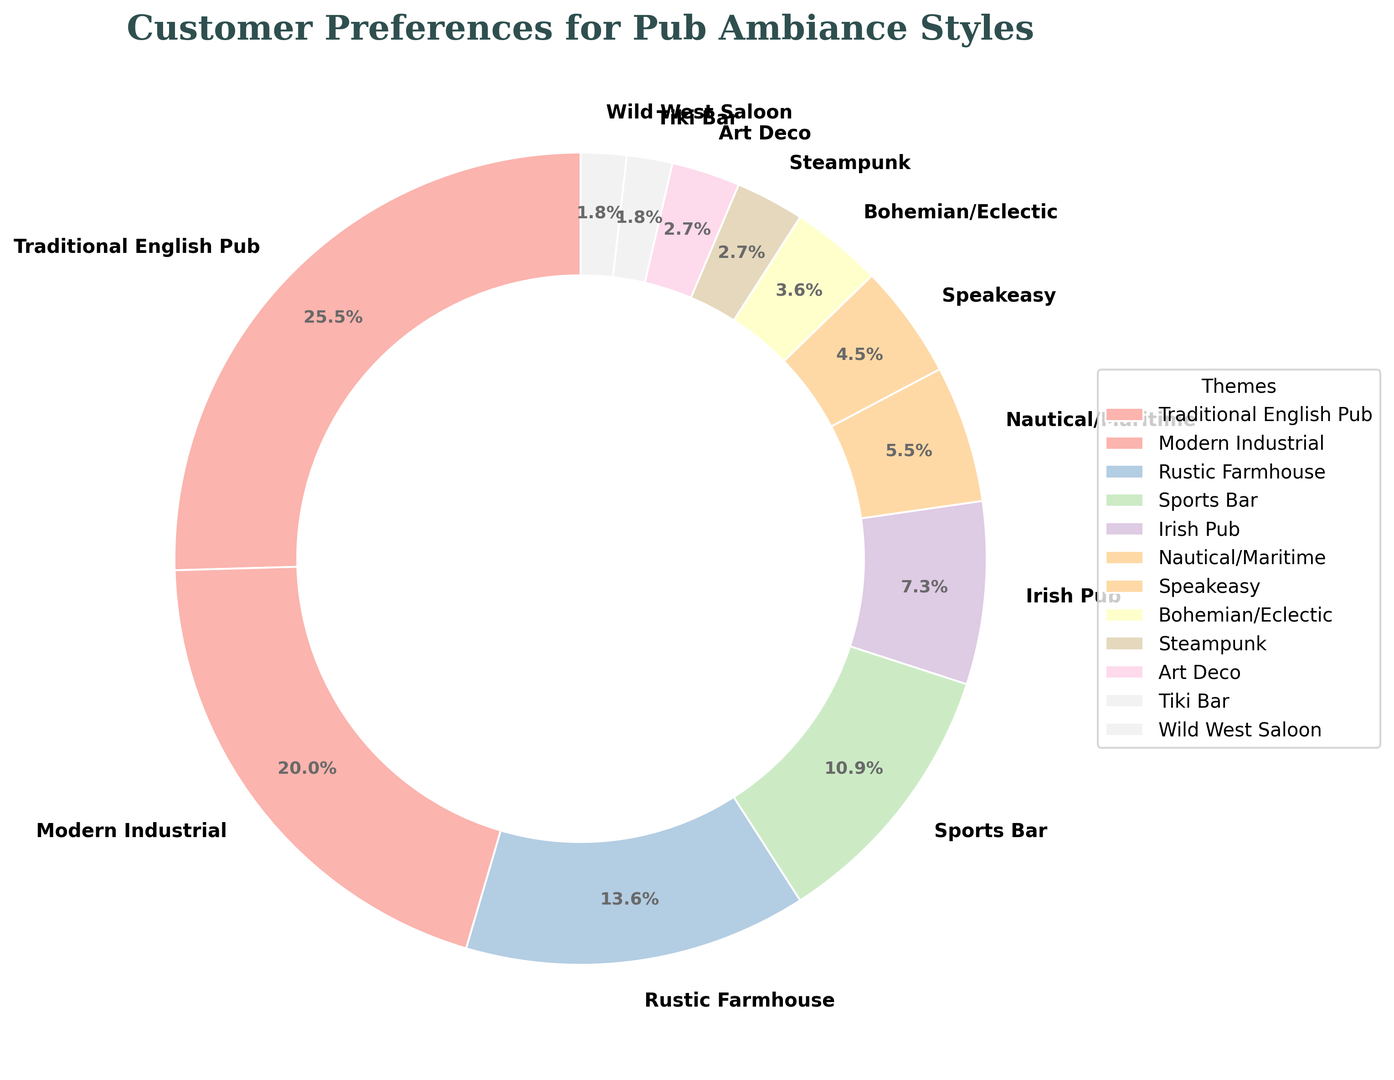Which ambiance style is preferred the most by customers? To determine the most preferred ambiance style, look for the segment with the largest percentage in the pie chart. The Traditional English Pub segment is the largest with 28%.
Answer: Traditional English Pub What is the combined percentage of customers who prefer either Traditional English Pub or Modern Industrial styles? Add the percentages of customers who prefer Traditional English Pub (28%) and Modern Industrial (22%). So, 28% + 22% = 50%.
Answer: 50% Is the Rustic Farmhouse ambiance more popular than the Sports Bar ambiance? Compare the percentages of Rustic Farmhouse (15%) and Sports Bar (12%). Since 15% is greater than 12%, Rustic Farmhouse is more popular.
Answer: Yes Which ambiance style is least preferred by customers? The least preferred style will have the smallest percentage in the pie chart. The Tiki Bar and Wild West Saloon each have the smallest segment at 2%.
Answer: Tiki Bar and Wild West Saloon Calculate the difference in popularity between the Modern Industrial and Irish Pub styles. Subtract the percentage of Irish Pub (8%) from the percentage of Modern Industrial (22%). So, 22% - 8% = 14%.
Answer: 14% How many ambiance styles have a preference percentage less than or equal to 5%? Identify and count the segments with a percentage less than or equal to 5%. The styles are Speakeasy (5%), Bohemian/Eclectic (4%), Steampunk (3%), Art Deco (3%), Tiki Bar (2%), and Wild West Saloon (2%), making a total of 6 styles.
Answer: 6 Is there an ambiance style that has exactly half the preference percentage of the Traditional English Pub? Half of the Traditional English Pub’s percentage (28%) is 14%. None of the ambiance styles have a percentage exactly equal to 14%.
Answer: No Which three ambiance styles make up exactly 20% of the customer preferences? Identify themes that add up to 20%. Sports Bar (12%), Irish Pub (8%), and Nautical/Maritime (6%) sum to 12% + 8% = 20%. Since there's an overlap, consider smaller values. Steampunk (3%), Art Deco (3%), Tiki Bar (2%), and Wild West Saloon (2%) sum to 3% + 3% + 2% + 2% = 10%. Reiterate considering the combinations with Speakeasy. However, the sum of exact 20% forms from Sports Bar and Irish Pub. So, for accurate value check addition of refined values.
Answer: Sports Bar, Irish Pub What is the total percentage for all ambiance styles that are preferred by fewer than 10% of customers each? Add up the percentages of Nautical/Maritime (6%), Speakeasy (5%), Bohemian/Eclectic (4%), Steampunk (3%), Art Deco (3%), Tiki Bar (2%), and Wild West Saloon (2%). So, 6% + 5% + 4% + 3% + 3% + 2% + 2% = 25%.
Answer: 25% Which color is used to represent the Traditional English Pub in the pie chart? Identify the color applied to the segment labeled as Traditional English Pub. As per color palette mapping applied, Pastel shades can translate for readable attributes for visual comprehension. Initial section is rendered with dynamic visible lighter colors represented visually with distinctive identification, denoting each set. Accordingly gauged could infer initial hue space, depicted as accommodated pastel-tone uniformly.
Answer: Pink/Light representations distinctively acknowledged in lighter visual segmentations 